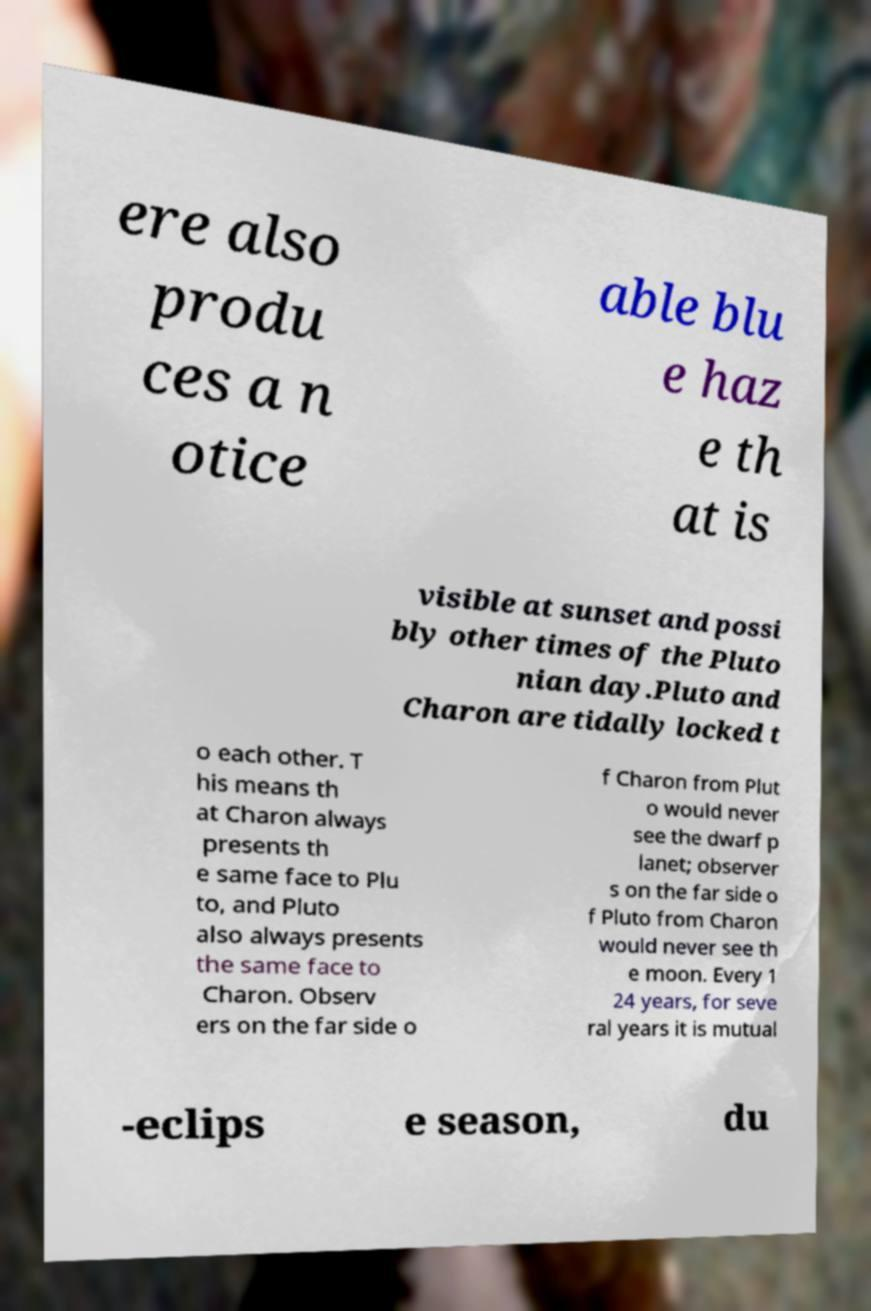Can you accurately transcribe the text from the provided image for me? ere also produ ces a n otice able blu e haz e th at is visible at sunset and possi bly other times of the Pluto nian day.Pluto and Charon are tidally locked t o each other. T his means th at Charon always presents th e same face to Plu to, and Pluto also always presents the same face to Charon. Observ ers on the far side o f Charon from Plut o would never see the dwarf p lanet; observer s on the far side o f Pluto from Charon would never see th e moon. Every 1 24 years, for seve ral years it is mutual -eclips e season, du 